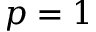<formula> <loc_0><loc_0><loc_500><loc_500>p = 1</formula> 